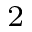<formula> <loc_0><loc_0><loc_500><loc_500>^ { 2 }</formula> 